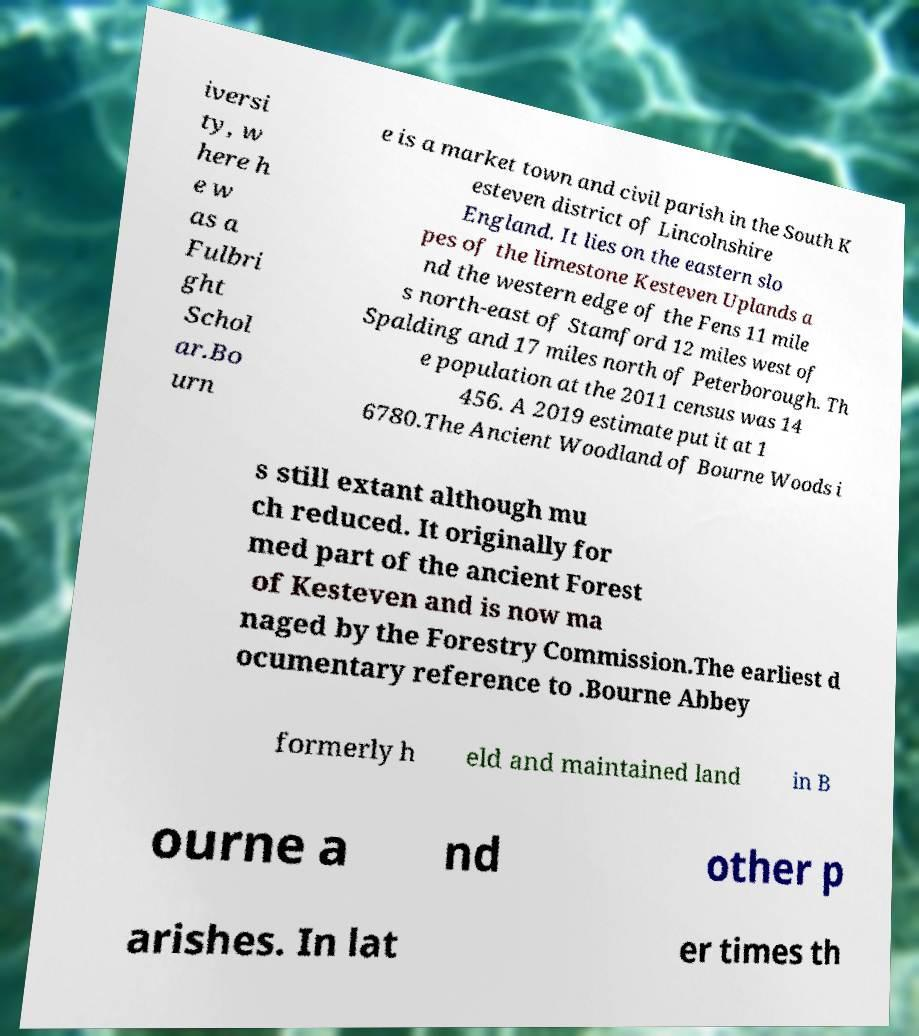Please read and relay the text visible in this image. What does it say? iversi ty, w here h e w as a Fulbri ght Schol ar.Bo urn e is a market town and civil parish in the South K esteven district of Lincolnshire England. It lies on the eastern slo pes of the limestone Kesteven Uplands a nd the western edge of the Fens 11 mile s north-east of Stamford 12 miles west of Spalding and 17 miles north of Peterborough. Th e population at the 2011 census was 14 456. A 2019 estimate put it at 1 6780.The Ancient Woodland of Bourne Woods i s still extant although mu ch reduced. It originally for med part of the ancient Forest of Kesteven and is now ma naged by the Forestry Commission.The earliest d ocumentary reference to .Bourne Abbey formerly h eld and maintained land in B ourne a nd other p arishes. In lat er times th 